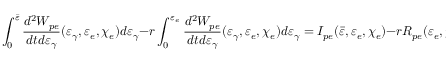Convert formula to latex. <formula><loc_0><loc_0><loc_500><loc_500>\int _ { 0 } ^ { \bar { \varepsilon } } \frac { d ^ { 2 } W _ { p e } } { d t d \varepsilon _ { \gamma } } ( \varepsilon _ { \gamma } , \varepsilon _ { e } , \chi _ { e } ) d \varepsilon _ { \gamma } - r \int _ { 0 } ^ { \varepsilon _ { e } } \frac { d ^ { 2 } W _ { p e } } { d t d \varepsilon _ { \gamma } } ( \varepsilon _ { \gamma } , \varepsilon _ { e } , \chi _ { e } ) d \varepsilon _ { \gamma } = I _ { p e } ( \bar { \varepsilon } , \varepsilon _ { e } , \chi _ { e } ) - r R _ { p e } ( \varepsilon _ { e } , \chi _ { e } ) = 0 ,</formula> 